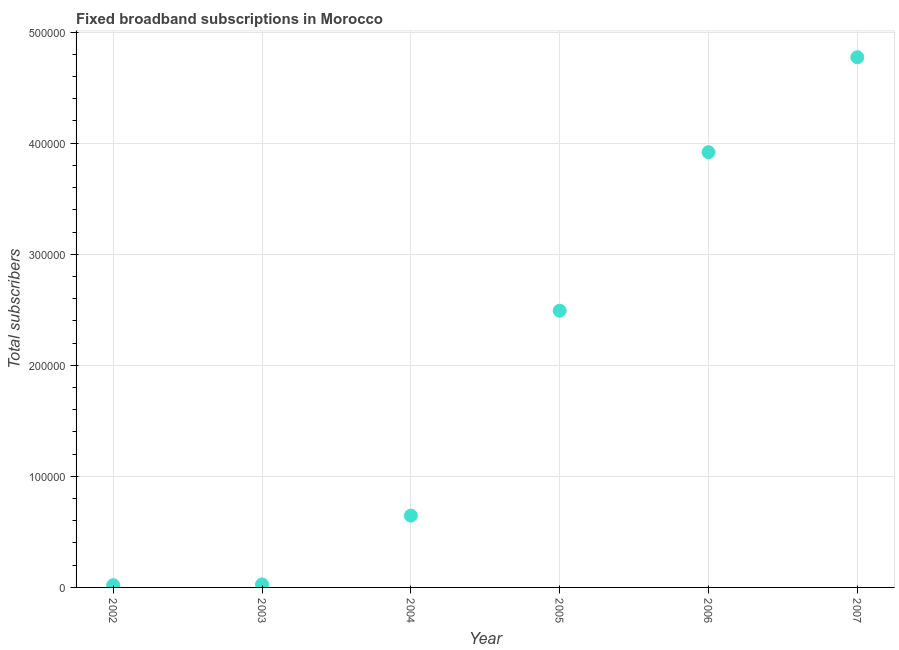What is the total number of fixed broadband subscriptions in 2003?
Ensure brevity in your answer.  2712. Across all years, what is the maximum total number of fixed broadband subscriptions?
Keep it short and to the point. 4.77e+05. In which year was the total number of fixed broadband subscriptions maximum?
Give a very brief answer. 2007. In which year was the total number of fixed broadband subscriptions minimum?
Your response must be concise. 2002. What is the sum of the total number of fixed broadband subscriptions?
Your answer should be very brief. 1.19e+06. What is the difference between the total number of fixed broadband subscriptions in 2003 and 2007?
Your answer should be very brief. -4.75e+05. What is the average total number of fixed broadband subscriptions per year?
Provide a succinct answer. 1.98e+05. What is the median total number of fixed broadband subscriptions?
Your answer should be very brief. 1.57e+05. In how many years, is the total number of fixed broadband subscriptions greater than 160000 ?
Your response must be concise. 3. Do a majority of the years between 2006 and 2007 (inclusive) have total number of fixed broadband subscriptions greater than 100000 ?
Provide a succinct answer. Yes. What is the ratio of the total number of fixed broadband subscriptions in 2002 to that in 2005?
Your response must be concise. 0.01. Is the difference between the total number of fixed broadband subscriptions in 2002 and 2006 greater than the difference between any two years?
Your answer should be very brief. No. What is the difference between the highest and the second highest total number of fixed broadband subscriptions?
Make the answer very short. 8.55e+04. What is the difference between the highest and the lowest total number of fixed broadband subscriptions?
Provide a short and direct response. 4.75e+05. In how many years, is the total number of fixed broadband subscriptions greater than the average total number of fixed broadband subscriptions taken over all years?
Keep it short and to the point. 3. Does the total number of fixed broadband subscriptions monotonically increase over the years?
Give a very brief answer. Yes. What is the title of the graph?
Give a very brief answer. Fixed broadband subscriptions in Morocco. What is the label or title of the Y-axis?
Provide a short and direct response. Total subscribers. What is the Total subscribers in 2003?
Your response must be concise. 2712. What is the Total subscribers in 2004?
Offer a very short reply. 6.47e+04. What is the Total subscribers in 2005?
Your answer should be compact. 2.49e+05. What is the Total subscribers in 2006?
Your answer should be very brief. 3.92e+05. What is the Total subscribers in 2007?
Provide a short and direct response. 4.77e+05. What is the difference between the Total subscribers in 2002 and 2003?
Your answer should be compact. -712. What is the difference between the Total subscribers in 2002 and 2004?
Offer a terse response. -6.27e+04. What is the difference between the Total subscribers in 2002 and 2005?
Make the answer very short. -2.47e+05. What is the difference between the Total subscribers in 2002 and 2006?
Offer a terse response. -3.90e+05. What is the difference between the Total subscribers in 2002 and 2007?
Make the answer very short. -4.75e+05. What is the difference between the Total subscribers in 2003 and 2004?
Provide a short and direct response. -6.19e+04. What is the difference between the Total subscribers in 2003 and 2005?
Keep it short and to the point. -2.46e+05. What is the difference between the Total subscribers in 2003 and 2006?
Provide a short and direct response. -3.89e+05. What is the difference between the Total subscribers in 2003 and 2007?
Your answer should be very brief. -4.75e+05. What is the difference between the Total subscribers in 2004 and 2005?
Provide a succinct answer. -1.84e+05. What is the difference between the Total subscribers in 2004 and 2006?
Your response must be concise. -3.27e+05. What is the difference between the Total subscribers in 2004 and 2007?
Offer a terse response. -4.13e+05. What is the difference between the Total subscribers in 2005 and 2006?
Offer a very short reply. -1.43e+05. What is the difference between the Total subscribers in 2005 and 2007?
Give a very brief answer. -2.28e+05. What is the difference between the Total subscribers in 2006 and 2007?
Your response must be concise. -8.55e+04. What is the ratio of the Total subscribers in 2002 to that in 2003?
Give a very brief answer. 0.74. What is the ratio of the Total subscribers in 2002 to that in 2004?
Your response must be concise. 0.03. What is the ratio of the Total subscribers in 2002 to that in 2005?
Provide a succinct answer. 0.01. What is the ratio of the Total subscribers in 2002 to that in 2006?
Ensure brevity in your answer.  0.01. What is the ratio of the Total subscribers in 2002 to that in 2007?
Your answer should be compact. 0. What is the ratio of the Total subscribers in 2003 to that in 2004?
Offer a terse response. 0.04. What is the ratio of the Total subscribers in 2003 to that in 2005?
Give a very brief answer. 0.01. What is the ratio of the Total subscribers in 2003 to that in 2006?
Keep it short and to the point. 0.01. What is the ratio of the Total subscribers in 2003 to that in 2007?
Your answer should be very brief. 0.01. What is the ratio of the Total subscribers in 2004 to that in 2005?
Ensure brevity in your answer.  0.26. What is the ratio of the Total subscribers in 2004 to that in 2006?
Give a very brief answer. 0.17. What is the ratio of the Total subscribers in 2004 to that in 2007?
Keep it short and to the point. 0.14. What is the ratio of the Total subscribers in 2005 to that in 2006?
Your response must be concise. 0.64. What is the ratio of the Total subscribers in 2005 to that in 2007?
Keep it short and to the point. 0.52. What is the ratio of the Total subscribers in 2006 to that in 2007?
Give a very brief answer. 0.82. 